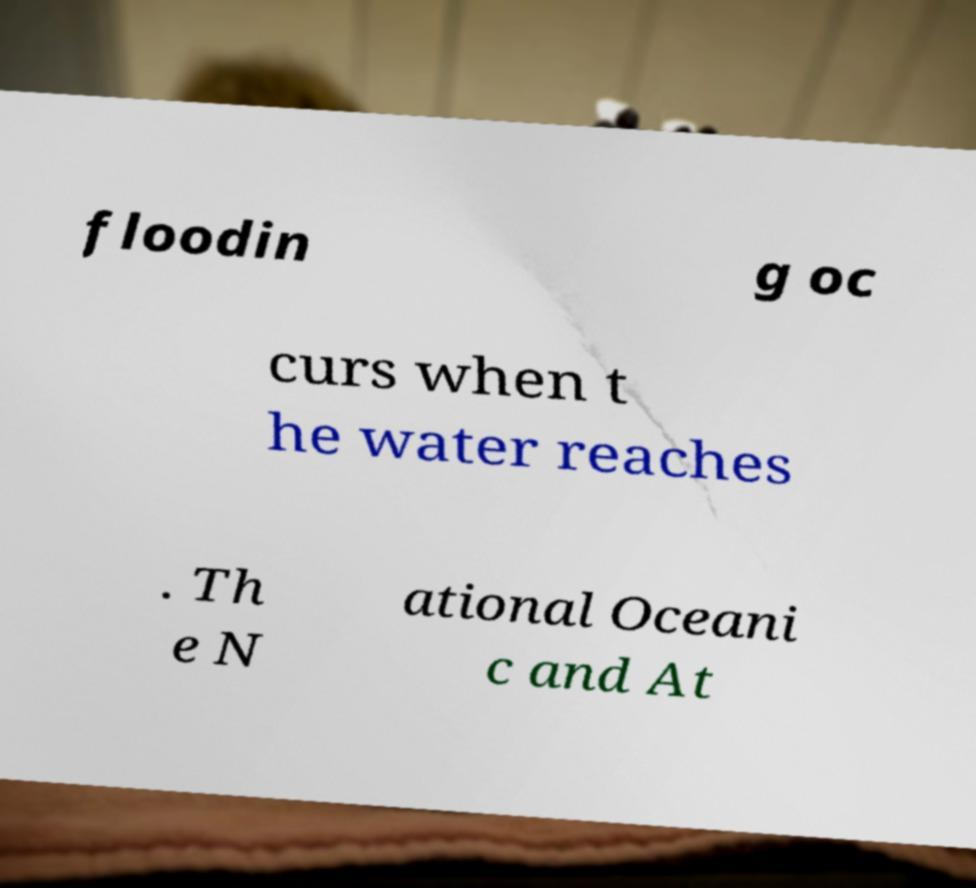Can you accurately transcribe the text from the provided image for me? floodin g oc curs when t he water reaches . Th e N ational Oceani c and At 